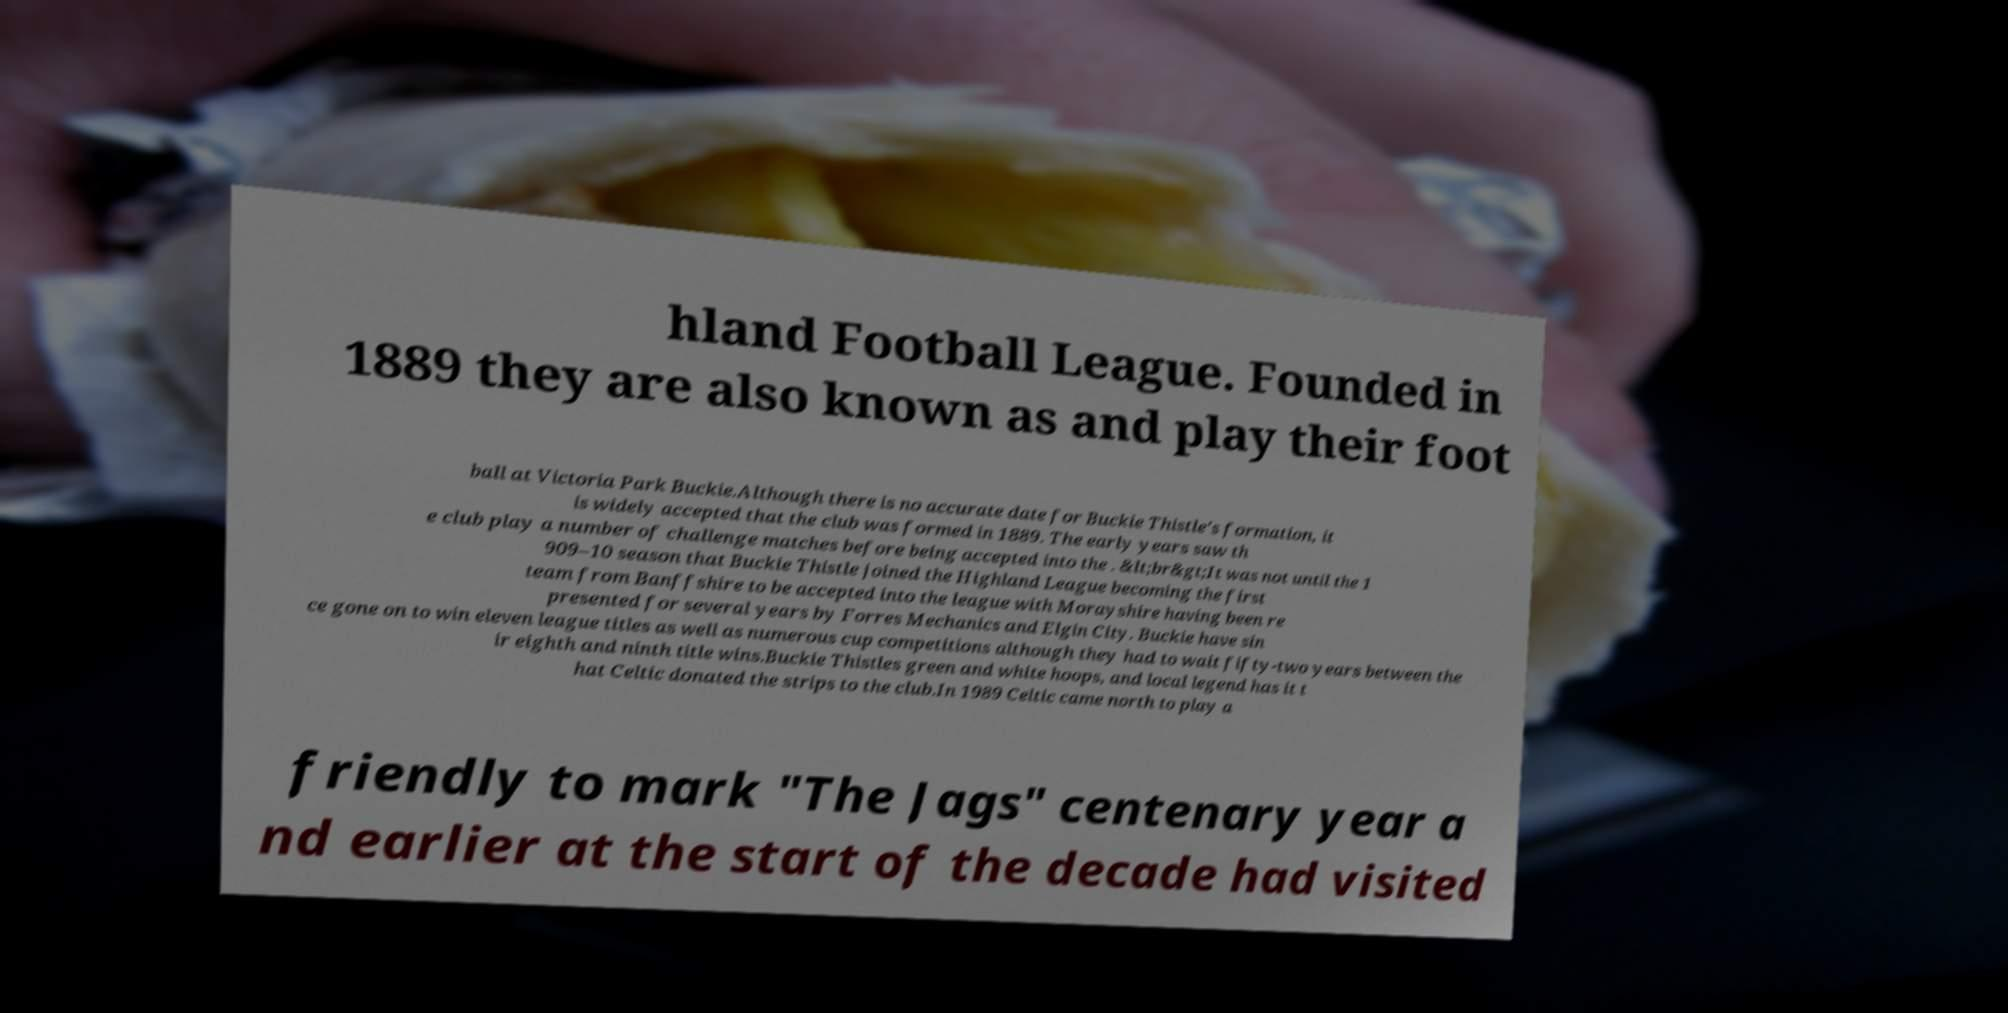What messages or text are displayed in this image? I need them in a readable, typed format. hland Football League. Founded in 1889 they are also known as and play their foot ball at Victoria Park Buckie.Although there is no accurate date for Buckie Thistle's formation, it is widely accepted that the club was formed in 1889. The early years saw th e club play a number of challenge matches before being accepted into the . &lt;br&gt;It was not until the 1 909–10 season that Buckie Thistle joined the Highland League becoming the first team from Banffshire to be accepted into the league with Morayshire having been re presented for several years by Forres Mechanics and Elgin City. Buckie have sin ce gone on to win eleven league titles as well as numerous cup competitions although they had to wait fifty-two years between the ir eighth and ninth title wins.Buckie Thistles green and white hoops, and local legend has it t hat Celtic donated the strips to the club.In 1989 Celtic came north to play a friendly to mark "The Jags" centenary year a nd earlier at the start of the decade had visited 